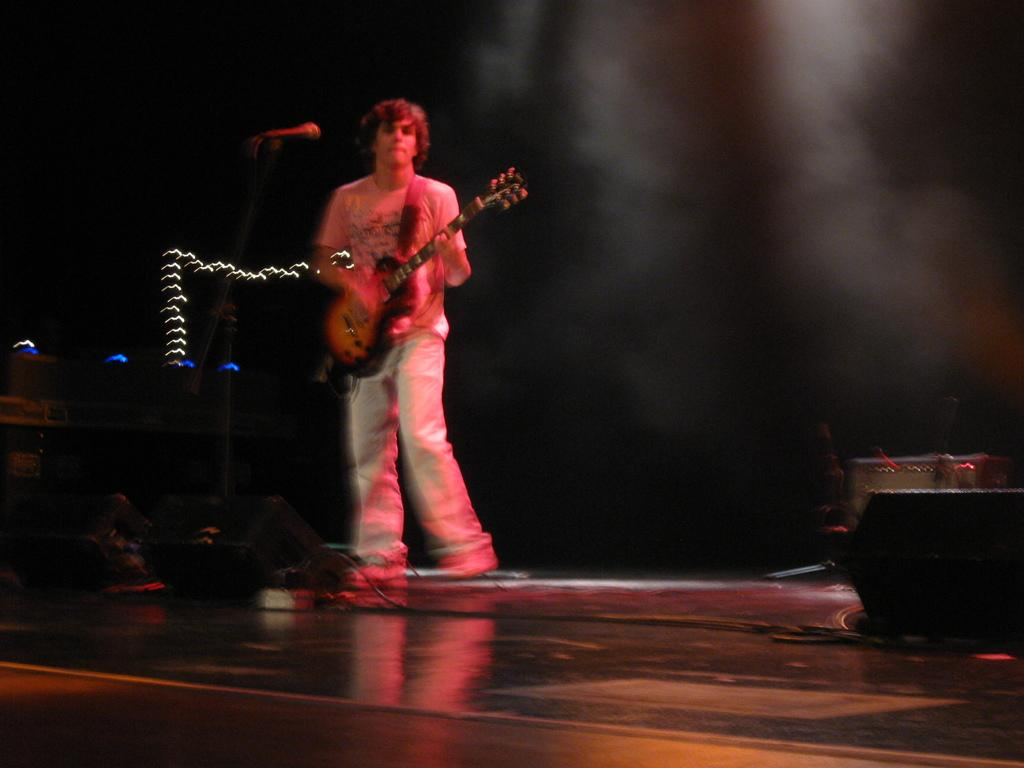What is the person on the stage doing? The person is standing on a stage and holding a guitar. What might the person be using to amplify their voice? There is a microphone in front of the person. What equipment is present to enhance the sound during the performance? There is a sound system present. How much dirt is visible on the stage in the image? There is no dirt visible on the stage in the image. What is the rate of the person's heartbeat during the performance? The image does not provide information about the person's heartbeat, so we cannot determine the rate. 